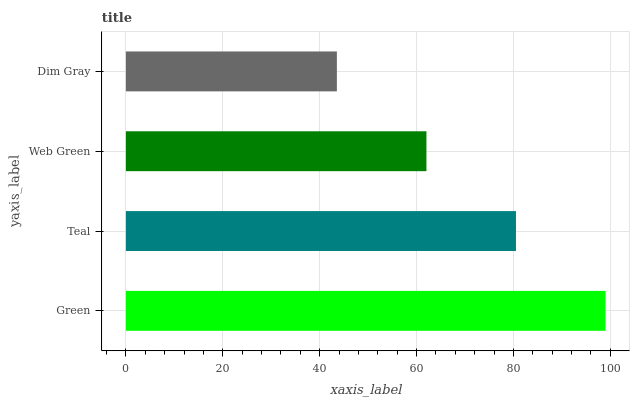Is Dim Gray the minimum?
Answer yes or no. Yes. Is Green the maximum?
Answer yes or no. Yes. Is Teal the minimum?
Answer yes or no. No. Is Teal the maximum?
Answer yes or no. No. Is Green greater than Teal?
Answer yes or no. Yes. Is Teal less than Green?
Answer yes or no. Yes. Is Teal greater than Green?
Answer yes or no. No. Is Green less than Teal?
Answer yes or no. No. Is Teal the high median?
Answer yes or no. Yes. Is Web Green the low median?
Answer yes or no. Yes. Is Web Green the high median?
Answer yes or no. No. Is Dim Gray the low median?
Answer yes or no. No. 